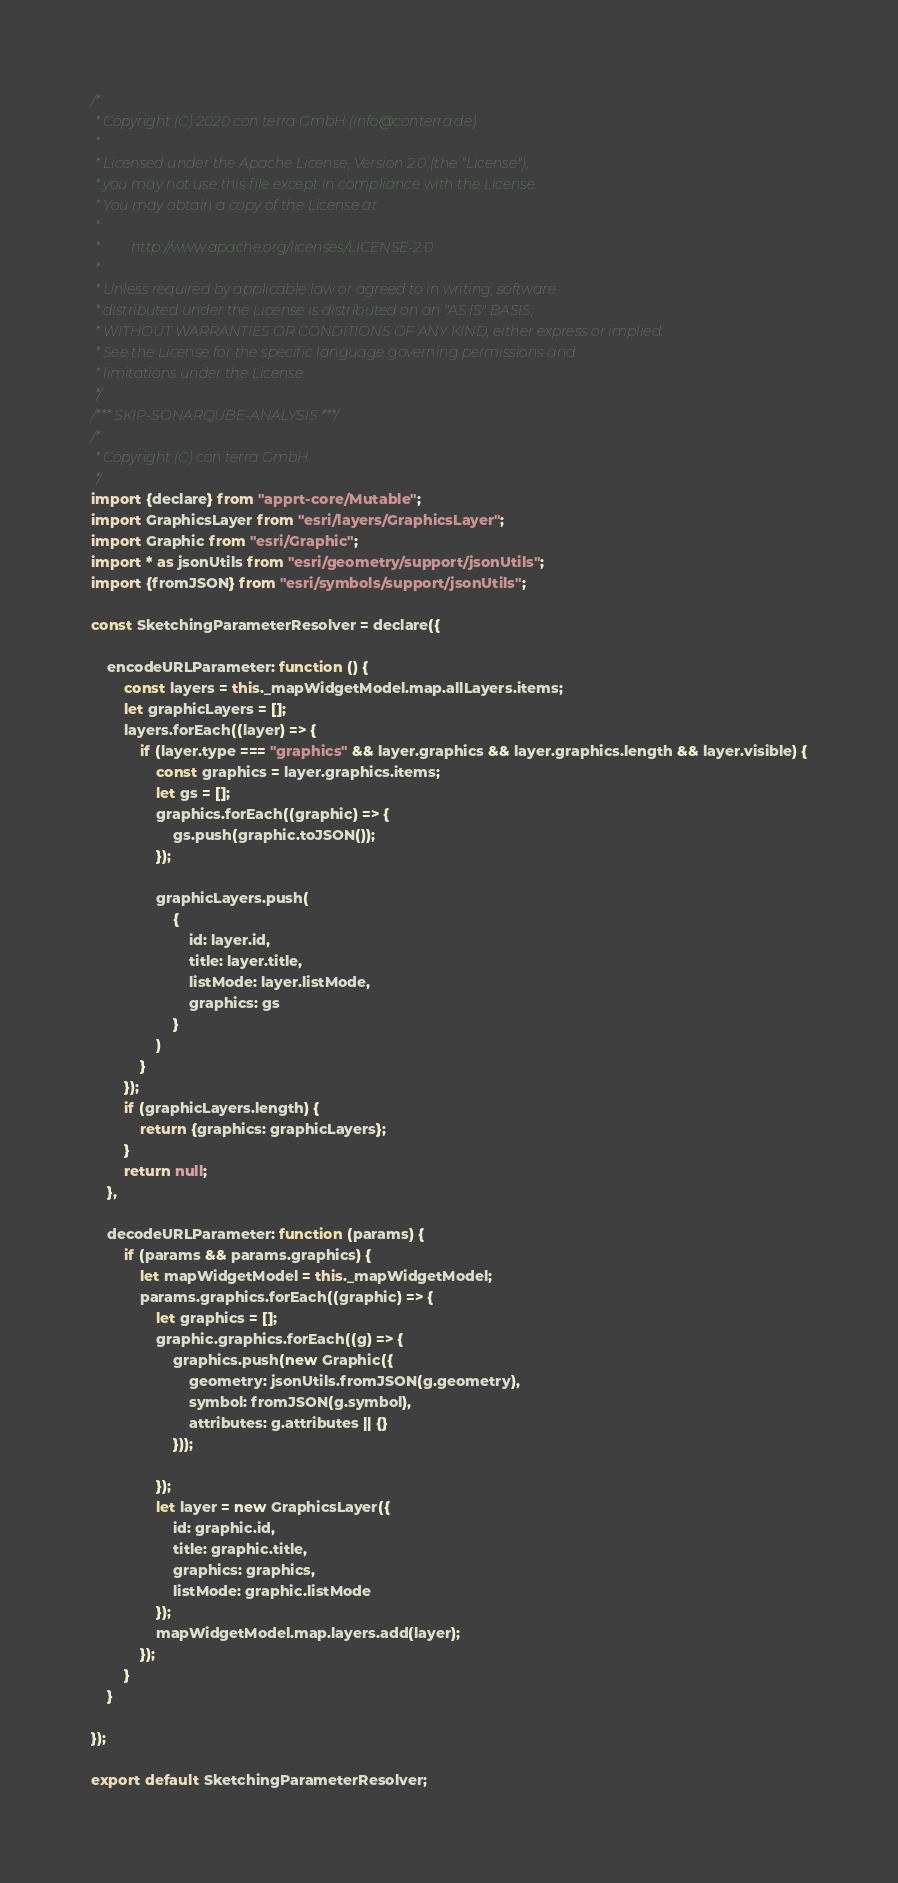Convert code to text. <code><loc_0><loc_0><loc_500><loc_500><_JavaScript_>/*
 * Copyright (C) 2020 con terra GmbH (info@conterra.de)
 *
 * Licensed under the Apache License, Version 2.0 (the "License");
 * you may not use this file except in compliance with the License.
 * You may obtain a copy of the License at
 *
 *         http://www.apache.org/licenses/LICENSE-2.0
 *
 * Unless required by applicable law or agreed to in writing, software
 * distributed under the License is distributed on an "AS IS" BASIS,
 * WITHOUT WARRANTIES OR CONDITIONS OF ANY KIND, either express or implied.
 * See the License for the specific language governing permissions and
 * limitations under the License.
 */
/*** SKIP-SONARQUBE-ANALYSIS ***/
/*
 * Copyright (C) con terra GmbH
 */
import {declare} from "apprt-core/Mutable";
import GraphicsLayer from "esri/layers/GraphicsLayer";
import Graphic from "esri/Graphic";
import * as jsonUtils from "esri/geometry/support/jsonUtils";
import {fromJSON} from "esri/symbols/support/jsonUtils";

const SketchingParameterResolver = declare({

    encodeURLParameter: function () {
        const layers = this._mapWidgetModel.map.allLayers.items;
        let graphicLayers = [];
        layers.forEach((layer) => {
            if (layer.type === "graphics" && layer.graphics && layer.graphics.length && layer.visible) {
                const graphics = layer.graphics.items;
                let gs = [];
                graphics.forEach((graphic) => {
                    gs.push(graphic.toJSON());
                });

                graphicLayers.push(
                    {
                        id: layer.id,
                        title: layer.title,
                        listMode: layer.listMode,
                        graphics: gs
                    }
                )
            }
        });
        if (graphicLayers.length) {
            return {graphics: graphicLayers};
        }
        return null;
    },

    decodeURLParameter: function (params) {
        if (params && params.graphics) {
            let mapWidgetModel = this._mapWidgetModel;
            params.graphics.forEach((graphic) => {
                let graphics = [];
                graphic.graphics.forEach((g) => {
                    graphics.push(new Graphic({
                        geometry: jsonUtils.fromJSON(g.geometry),
                        symbol: fromJSON(g.symbol),
                        attributes: g.attributes || {}
                    }));

                });
                let layer = new GraphicsLayer({
                    id: graphic.id,
                    title: graphic.title,
                    graphics: graphics,
                    listMode: graphic.listMode
                });
                mapWidgetModel.map.layers.add(layer);
            });
        }
    }

});

export default SketchingParameterResolver;
</code> 